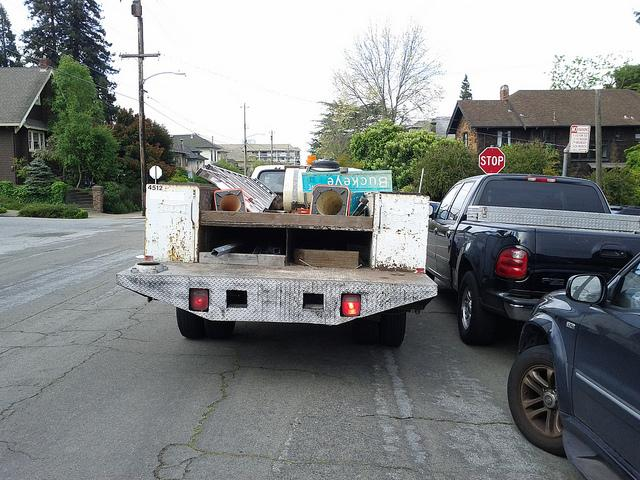Asphalts are used to construct what? roads 